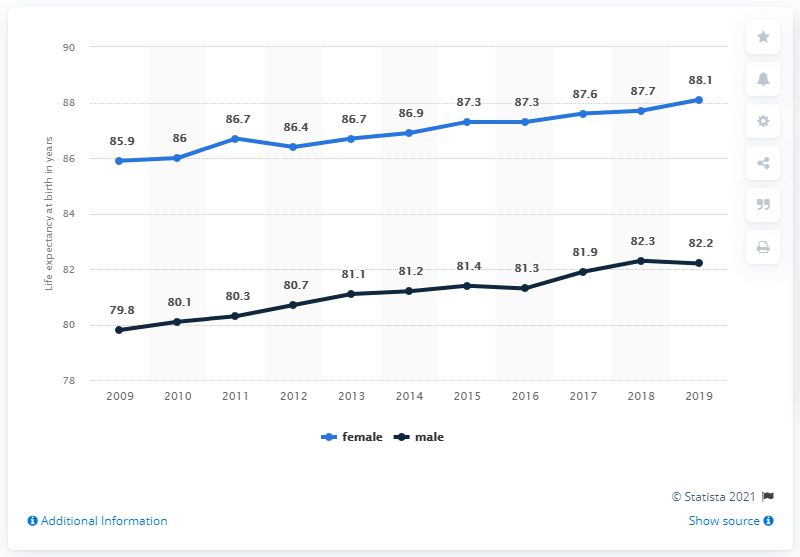Specify some key components in this picture. The median value of female life expectancy at birth from 2009 to 2013 was 86.4 years. According to data available in 2018, the male life expectancy at birth was 82.3 years. 